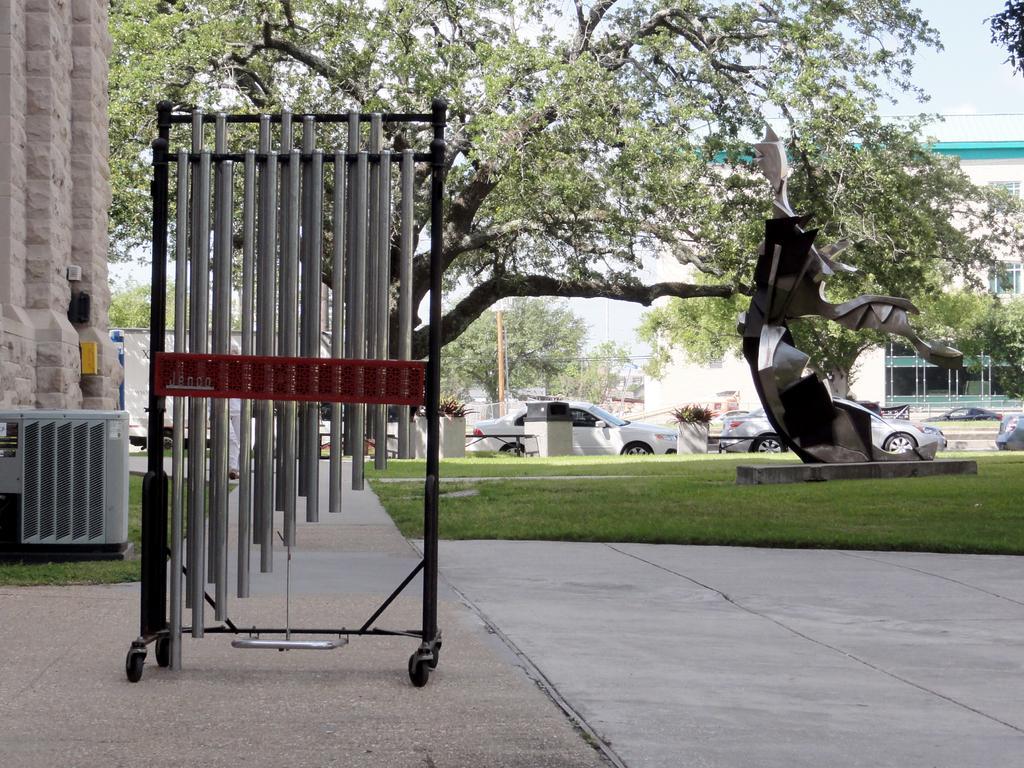Please provide a concise description of this image. In this image we can see a sculpture on the grassy land. Behind the sculpture, we can see potted plants, cars, building and trees. On the left side of the image, we can see a fence, a machine and a wall. Behind the tree, we can see the sky. At the bottom of the image, we can see the pavement. 